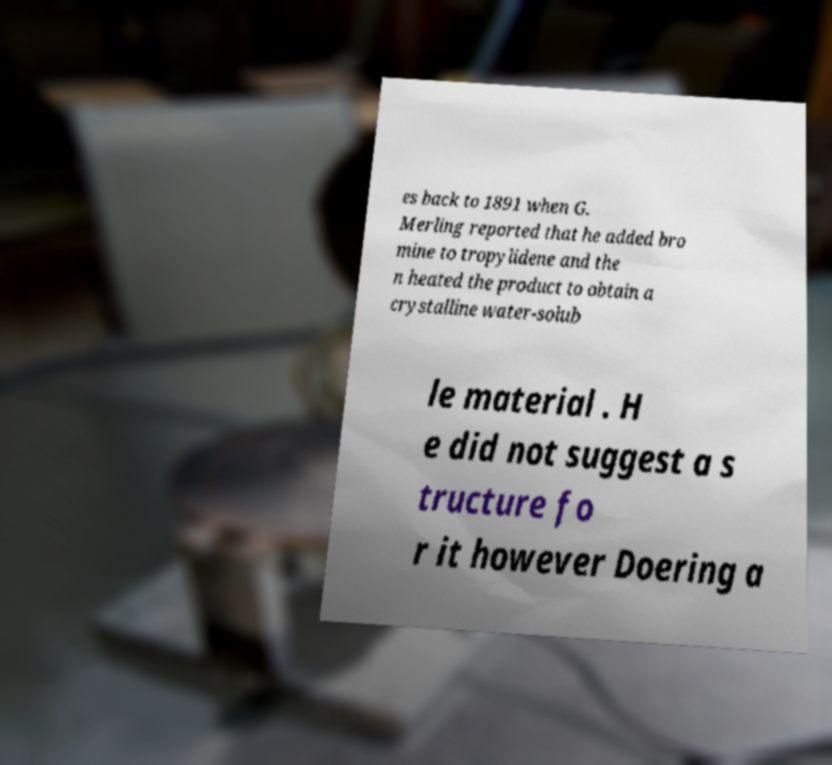For documentation purposes, I need the text within this image transcribed. Could you provide that? es back to 1891 when G. Merling reported that he added bro mine to tropylidene and the n heated the product to obtain a crystalline water-solub le material . H e did not suggest a s tructure fo r it however Doering a 